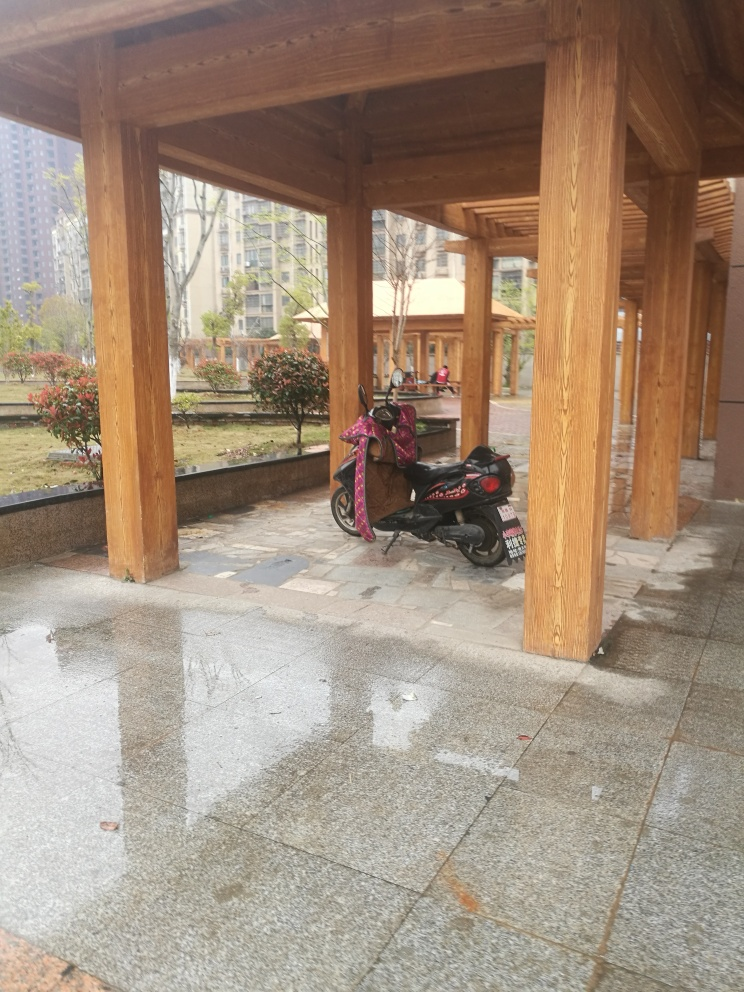Can you comment on the architectural style depicted in the image? The photograph showcases wooden beams and pillars that are characteristic of a pavilion-like structure, suggesting an architectural style that places an emphasis on open spaces and functional areas that provide shelter. The simplicity and robustness of the wooden construction could be indicative of influences from traditional East Asian architecture. What feeling does this image evoke? The image conveys a serene and peaceful ambiance. The absence of people and the presence of the parked scooter add to the tranquility, portraying a quiet moment in an otherwise active space. The wet ground reflects the surroundings, creating a sense of stillness and contemplation. 